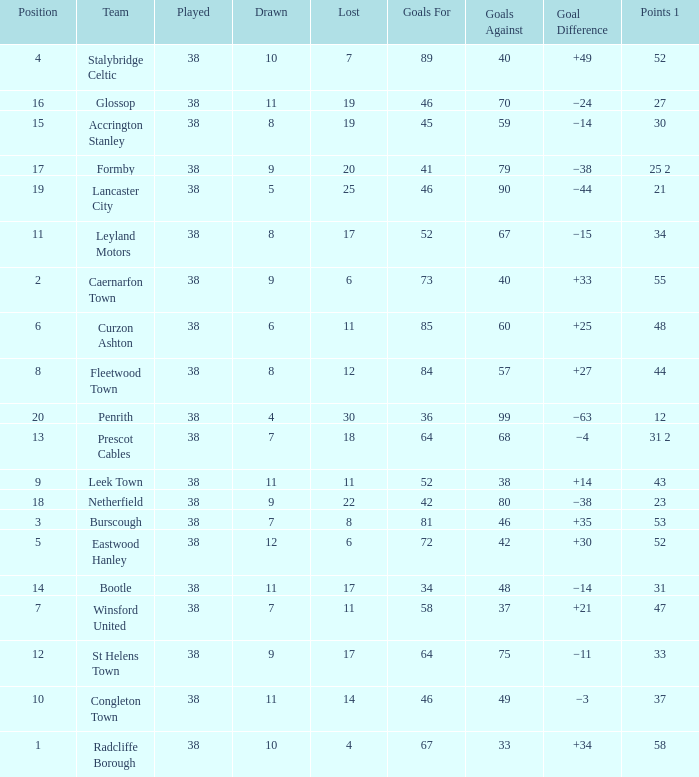Parse the full table. {'header': ['Position', 'Team', 'Played', 'Drawn', 'Lost', 'Goals For', 'Goals Against', 'Goal Difference', 'Points 1'], 'rows': [['4', 'Stalybridge Celtic', '38', '10', '7', '89', '40', '+49', '52'], ['16', 'Glossop', '38', '11', '19', '46', '70', '−24', '27'], ['15', 'Accrington Stanley', '38', '8', '19', '45', '59', '−14', '30'], ['17', 'Formby', '38', '9', '20', '41', '79', '−38', '25 2'], ['19', 'Lancaster City', '38', '5', '25', '46', '90', '−44', '21'], ['11', 'Leyland Motors', '38', '8', '17', '52', '67', '−15', '34'], ['2', 'Caernarfon Town', '38', '9', '6', '73', '40', '+33', '55'], ['6', 'Curzon Ashton', '38', '6', '11', '85', '60', '+25', '48'], ['8', 'Fleetwood Town', '38', '8', '12', '84', '57', '+27', '44'], ['20', 'Penrith', '38', '4', '30', '36', '99', '−63', '12'], ['13', 'Prescot Cables', '38', '7', '18', '64', '68', '−4', '31 2'], ['9', 'Leek Town', '38', '11', '11', '52', '38', '+14', '43'], ['18', 'Netherfield', '38', '9', '22', '42', '80', '−38', '23'], ['3', 'Burscough', '38', '7', '8', '81', '46', '+35', '53'], ['5', 'Eastwood Hanley', '38', '12', '6', '72', '42', '+30', '52'], ['14', 'Bootle', '38', '11', '17', '34', '48', '−14', '31'], ['7', 'Winsford United', '38', '7', '11', '58', '37', '+21', '47'], ['12', 'St Helens Town', '38', '9', '17', '64', '75', '−11', '33'], ['10', 'Congleton Town', '38', '11', '14', '46', '49', '−3', '37'], ['1', 'Radcliffe Borough', '38', '10', '4', '67', '33', '+34', '58']]} WHAT IS THE LOST WITH A DRAWN 11, FOR LEEK TOWN? 11.0. 